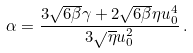Convert formula to latex. <formula><loc_0><loc_0><loc_500><loc_500>\alpha = \frac { 3 \sqrt { 6 \beta } \gamma + 2 \sqrt { 6 \beta } \eta u _ { 0 } ^ { 4 } } { 3 \sqrt { \eta } u _ { 0 } ^ { 2 } } \, .</formula> 